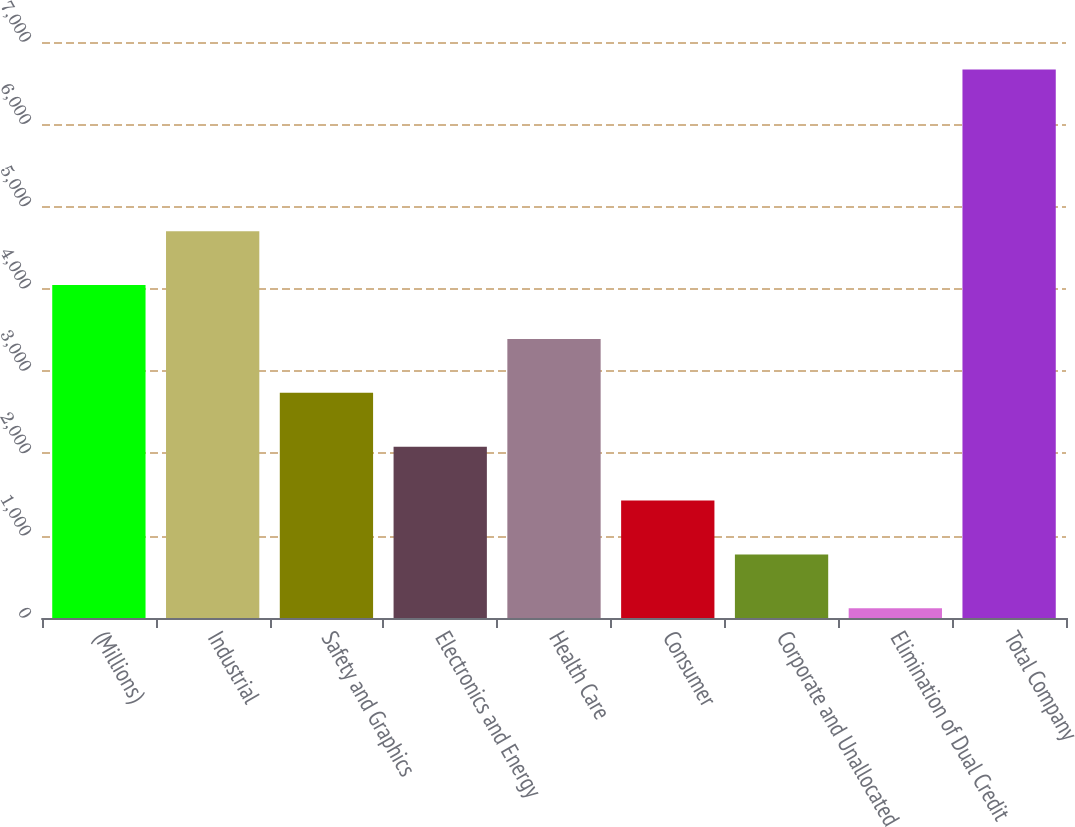Convert chart. <chart><loc_0><loc_0><loc_500><loc_500><bar_chart><fcel>(Millions)<fcel>Industrial<fcel>Safety and Graphics<fcel>Electronics and Energy<fcel>Health Care<fcel>Consumer<fcel>Corporate and Unallocated<fcel>Elimination of Dual Credit<fcel>Total Company<nl><fcel>4046.8<fcel>4701.6<fcel>2737.2<fcel>2082.4<fcel>3392<fcel>1427.6<fcel>772.8<fcel>118<fcel>6666<nl></chart> 